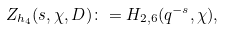Convert formula to latex. <formula><loc_0><loc_0><loc_500><loc_500>Z _ { h _ { 4 } } ( s , \chi , D ) \colon = H _ { 2 , 6 } ( q ^ { - s } , \chi ) ,</formula> 